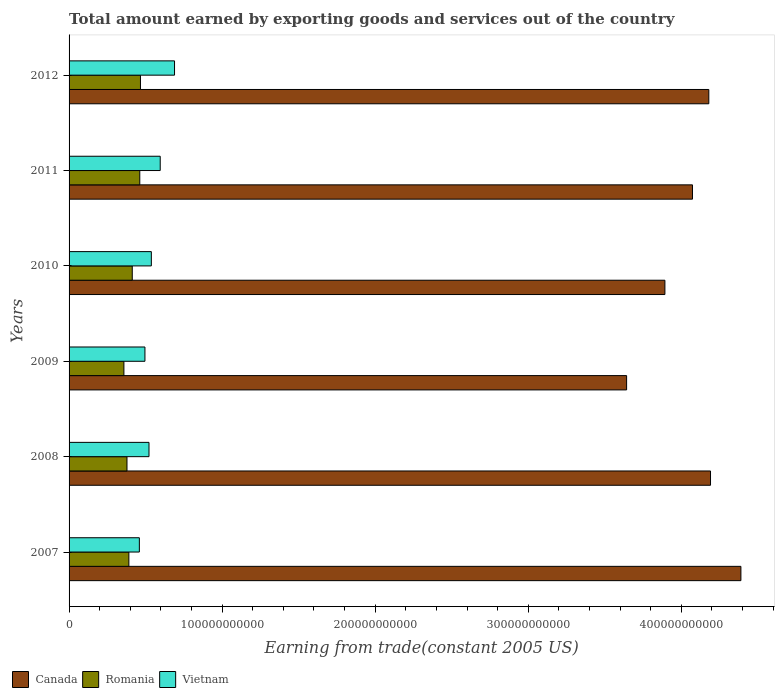How many different coloured bars are there?
Provide a succinct answer. 3. Are the number of bars per tick equal to the number of legend labels?
Give a very brief answer. Yes. How many bars are there on the 1st tick from the top?
Make the answer very short. 3. What is the label of the 1st group of bars from the top?
Keep it short and to the point. 2012. What is the total amount earned by exporting goods and services in Vietnam in 2011?
Give a very brief answer. 5.95e+1. Across all years, what is the maximum total amount earned by exporting goods and services in Vietnam?
Make the answer very short. 6.89e+1. Across all years, what is the minimum total amount earned by exporting goods and services in Canada?
Your answer should be very brief. 3.64e+11. In which year was the total amount earned by exporting goods and services in Canada maximum?
Make the answer very short. 2007. In which year was the total amount earned by exporting goods and services in Romania minimum?
Your answer should be compact. 2009. What is the total total amount earned by exporting goods and services in Canada in the graph?
Offer a very short reply. 2.44e+12. What is the difference between the total amount earned by exporting goods and services in Canada in 2007 and that in 2010?
Offer a terse response. 4.97e+1. What is the difference between the total amount earned by exporting goods and services in Vietnam in 2007 and the total amount earned by exporting goods and services in Canada in 2012?
Provide a succinct answer. -3.72e+11. What is the average total amount earned by exporting goods and services in Vietnam per year?
Give a very brief answer. 5.50e+1. In the year 2011, what is the difference between the total amount earned by exporting goods and services in Romania and total amount earned by exporting goods and services in Vietnam?
Provide a short and direct response. -1.34e+1. What is the ratio of the total amount earned by exporting goods and services in Canada in 2007 to that in 2009?
Provide a short and direct response. 1.2. What is the difference between the highest and the second highest total amount earned by exporting goods and services in Vietnam?
Your answer should be very brief. 9.35e+09. What is the difference between the highest and the lowest total amount earned by exporting goods and services in Romania?
Keep it short and to the point. 1.08e+1. Is the sum of the total amount earned by exporting goods and services in Canada in 2010 and 2011 greater than the maximum total amount earned by exporting goods and services in Vietnam across all years?
Make the answer very short. Yes. What does the 1st bar from the top in 2009 represents?
Provide a succinct answer. Vietnam. What does the 3rd bar from the bottom in 2012 represents?
Ensure brevity in your answer.  Vietnam. How many bars are there?
Your answer should be very brief. 18. Are all the bars in the graph horizontal?
Make the answer very short. Yes. How many years are there in the graph?
Give a very brief answer. 6. What is the difference between two consecutive major ticks on the X-axis?
Offer a terse response. 1.00e+11. Are the values on the major ticks of X-axis written in scientific E-notation?
Your answer should be compact. No. Does the graph contain any zero values?
Offer a terse response. No. How are the legend labels stacked?
Provide a succinct answer. Horizontal. What is the title of the graph?
Keep it short and to the point. Total amount earned by exporting goods and services out of the country. Does "Lithuania" appear as one of the legend labels in the graph?
Keep it short and to the point. No. What is the label or title of the X-axis?
Provide a succinct answer. Earning from trade(constant 2005 US). What is the label or title of the Y-axis?
Offer a terse response. Years. What is the Earning from trade(constant 2005 US) in Canada in 2007?
Keep it short and to the point. 4.39e+11. What is the Earning from trade(constant 2005 US) in Romania in 2007?
Your answer should be very brief. 3.91e+1. What is the Earning from trade(constant 2005 US) of Vietnam in 2007?
Make the answer very short. 4.59e+1. What is the Earning from trade(constant 2005 US) of Canada in 2008?
Ensure brevity in your answer.  4.19e+11. What is the Earning from trade(constant 2005 US) in Romania in 2008?
Your response must be concise. 3.78e+1. What is the Earning from trade(constant 2005 US) of Vietnam in 2008?
Your response must be concise. 5.22e+1. What is the Earning from trade(constant 2005 US) in Canada in 2009?
Offer a terse response. 3.64e+11. What is the Earning from trade(constant 2005 US) in Romania in 2009?
Provide a succinct answer. 3.58e+1. What is the Earning from trade(constant 2005 US) of Vietnam in 2009?
Your answer should be very brief. 4.96e+1. What is the Earning from trade(constant 2005 US) of Canada in 2010?
Your answer should be compact. 3.89e+11. What is the Earning from trade(constant 2005 US) of Romania in 2010?
Offer a very short reply. 4.13e+1. What is the Earning from trade(constant 2005 US) in Vietnam in 2010?
Offer a very short reply. 5.38e+1. What is the Earning from trade(constant 2005 US) in Canada in 2011?
Offer a very short reply. 4.07e+11. What is the Earning from trade(constant 2005 US) in Romania in 2011?
Offer a very short reply. 4.62e+1. What is the Earning from trade(constant 2005 US) in Vietnam in 2011?
Make the answer very short. 5.95e+1. What is the Earning from trade(constant 2005 US) of Canada in 2012?
Keep it short and to the point. 4.18e+11. What is the Earning from trade(constant 2005 US) in Romania in 2012?
Give a very brief answer. 4.67e+1. What is the Earning from trade(constant 2005 US) in Vietnam in 2012?
Provide a succinct answer. 6.89e+1. Across all years, what is the maximum Earning from trade(constant 2005 US) in Canada?
Give a very brief answer. 4.39e+11. Across all years, what is the maximum Earning from trade(constant 2005 US) of Romania?
Offer a terse response. 4.67e+1. Across all years, what is the maximum Earning from trade(constant 2005 US) of Vietnam?
Keep it short and to the point. 6.89e+1. Across all years, what is the minimum Earning from trade(constant 2005 US) of Canada?
Provide a short and direct response. 3.64e+11. Across all years, what is the minimum Earning from trade(constant 2005 US) of Romania?
Your answer should be compact. 3.58e+1. Across all years, what is the minimum Earning from trade(constant 2005 US) of Vietnam?
Your answer should be very brief. 4.59e+1. What is the total Earning from trade(constant 2005 US) in Canada in the graph?
Provide a short and direct response. 2.44e+12. What is the total Earning from trade(constant 2005 US) in Romania in the graph?
Your response must be concise. 2.47e+11. What is the total Earning from trade(constant 2005 US) in Vietnam in the graph?
Your answer should be compact. 3.30e+11. What is the difference between the Earning from trade(constant 2005 US) of Canada in 2007 and that in 2008?
Your response must be concise. 1.99e+1. What is the difference between the Earning from trade(constant 2005 US) of Romania in 2007 and that in 2008?
Provide a succinct answer. 1.23e+09. What is the difference between the Earning from trade(constant 2005 US) of Vietnam in 2007 and that in 2008?
Your answer should be very brief. -6.29e+09. What is the difference between the Earning from trade(constant 2005 US) in Canada in 2007 and that in 2009?
Keep it short and to the point. 7.47e+1. What is the difference between the Earning from trade(constant 2005 US) in Romania in 2007 and that in 2009?
Your answer should be compact. 3.25e+09. What is the difference between the Earning from trade(constant 2005 US) in Vietnam in 2007 and that in 2009?
Offer a terse response. -3.64e+09. What is the difference between the Earning from trade(constant 2005 US) in Canada in 2007 and that in 2010?
Give a very brief answer. 4.97e+1. What is the difference between the Earning from trade(constant 2005 US) of Romania in 2007 and that in 2010?
Make the answer very short. -2.21e+09. What is the difference between the Earning from trade(constant 2005 US) of Vietnam in 2007 and that in 2010?
Provide a succinct answer. -7.82e+09. What is the difference between the Earning from trade(constant 2005 US) in Canada in 2007 and that in 2011?
Provide a short and direct response. 3.16e+1. What is the difference between the Earning from trade(constant 2005 US) of Romania in 2007 and that in 2011?
Give a very brief answer. -7.12e+09. What is the difference between the Earning from trade(constant 2005 US) in Vietnam in 2007 and that in 2011?
Offer a very short reply. -1.36e+1. What is the difference between the Earning from trade(constant 2005 US) of Canada in 2007 and that in 2012?
Your answer should be compact. 2.10e+1. What is the difference between the Earning from trade(constant 2005 US) of Romania in 2007 and that in 2012?
Give a very brief answer. -7.58e+09. What is the difference between the Earning from trade(constant 2005 US) in Vietnam in 2007 and that in 2012?
Offer a terse response. -2.30e+1. What is the difference between the Earning from trade(constant 2005 US) of Canada in 2008 and that in 2009?
Provide a succinct answer. 5.48e+1. What is the difference between the Earning from trade(constant 2005 US) of Romania in 2008 and that in 2009?
Offer a terse response. 2.01e+09. What is the difference between the Earning from trade(constant 2005 US) in Vietnam in 2008 and that in 2009?
Your answer should be compact. 2.66e+09. What is the difference between the Earning from trade(constant 2005 US) of Canada in 2008 and that in 2010?
Offer a very short reply. 2.98e+1. What is the difference between the Earning from trade(constant 2005 US) of Romania in 2008 and that in 2010?
Ensure brevity in your answer.  -3.44e+09. What is the difference between the Earning from trade(constant 2005 US) of Vietnam in 2008 and that in 2010?
Your answer should be compact. -1.53e+09. What is the difference between the Earning from trade(constant 2005 US) of Canada in 2008 and that in 2011?
Provide a succinct answer. 1.18e+1. What is the difference between the Earning from trade(constant 2005 US) in Romania in 2008 and that in 2011?
Your answer should be compact. -8.35e+09. What is the difference between the Earning from trade(constant 2005 US) of Vietnam in 2008 and that in 2011?
Your response must be concise. -7.33e+09. What is the difference between the Earning from trade(constant 2005 US) in Canada in 2008 and that in 2012?
Make the answer very short. 1.12e+09. What is the difference between the Earning from trade(constant 2005 US) in Romania in 2008 and that in 2012?
Provide a succinct answer. -8.81e+09. What is the difference between the Earning from trade(constant 2005 US) in Vietnam in 2008 and that in 2012?
Your answer should be compact. -1.67e+1. What is the difference between the Earning from trade(constant 2005 US) in Canada in 2009 and that in 2010?
Provide a short and direct response. -2.50e+1. What is the difference between the Earning from trade(constant 2005 US) in Romania in 2009 and that in 2010?
Your response must be concise. -5.46e+09. What is the difference between the Earning from trade(constant 2005 US) in Vietnam in 2009 and that in 2010?
Give a very brief answer. -4.19e+09. What is the difference between the Earning from trade(constant 2005 US) of Canada in 2009 and that in 2011?
Ensure brevity in your answer.  -4.30e+1. What is the difference between the Earning from trade(constant 2005 US) in Romania in 2009 and that in 2011?
Your response must be concise. -1.04e+1. What is the difference between the Earning from trade(constant 2005 US) of Vietnam in 2009 and that in 2011?
Make the answer very short. -9.98e+09. What is the difference between the Earning from trade(constant 2005 US) of Canada in 2009 and that in 2012?
Ensure brevity in your answer.  -5.37e+1. What is the difference between the Earning from trade(constant 2005 US) in Romania in 2009 and that in 2012?
Make the answer very short. -1.08e+1. What is the difference between the Earning from trade(constant 2005 US) in Vietnam in 2009 and that in 2012?
Provide a short and direct response. -1.93e+1. What is the difference between the Earning from trade(constant 2005 US) in Canada in 2010 and that in 2011?
Provide a succinct answer. -1.80e+1. What is the difference between the Earning from trade(constant 2005 US) of Romania in 2010 and that in 2011?
Provide a succinct answer. -4.91e+09. What is the difference between the Earning from trade(constant 2005 US) in Vietnam in 2010 and that in 2011?
Your answer should be compact. -5.80e+09. What is the difference between the Earning from trade(constant 2005 US) in Canada in 2010 and that in 2012?
Provide a short and direct response. -2.87e+1. What is the difference between the Earning from trade(constant 2005 US) in Romania in 2010 and that in 2012?
Offer a terse response. -5.37e+09. What is the difference between the Earning from trade(constant 2005 US) of Vietnam in 2010 and that in 2012?
Ensure brevity in your answer.  -1.52e+1. What is the difference between the Earning from trade(constant 2005 US) in Canada in 2011 and that in 2012?
Your answer should be compact. -1.07e+1. What is the difference between the Earning from trade(constant 2005 US) in Romania in 2011 and that in 2012?
Ensure brevity in your answer.  -4.58e+08. What is the difference between the Earning from trade(constant 2005 US) of Vietnam in 2011 and that in 2012?
Give a very brief answer. -9.35e+09. What is the difference between the Earning from trade(constant 2005 US) in Canada in 2007 and the Earning from trade(constant 2005 US) in Romania in 2008?
Give a very brief answer. 4.01e+11. What is the difference between the Earning from trade(constant 2005 US) of Canada in 2007 and the Earning from trade(constant 2005 US) of Vietnam in 2008?
Offer a very short reply. 3.87e+11. What is the difference between the Earning from trade(constant 2005 US) of Romania in 2007 and the Earning from trade(constant 2005 US) of Vietnam in 2008?
Give a very brief answer. -1.31e+1. What is the difference between the Earning from trade(constant 2005 US) in Canada in 2007 and the Earning from trade(constant 2005 US) in Romania in 2009?
Provide a succinct answer. 4.03e+11. What is the difference between the Earning from trade(constant 2005 US) in Canada in 2007 and the Earning from trade(constant 2005 US) in Vietnam in 2009?
Your response must be concise. 3.89e+11. What is the difference between the Earning from trade(constant 2005 US) of Romania in 2007 and the Earning from trade(constant 2005 US) of Vietnam in 2009?
Your response must be concise. -1.05e+1. What is the difference between the Earning from trade(constant 2005 US) in Canada in 2007 and the Earning from trade(constant 2005 US) in Romania in 2010?
Offer a terse response. 3.98e+11. What is the difference between the Earning from trade(constant 2005 US) of Canada in 2007 and the Earning from trade(constant 2005 US) of Vietnam in 2010?
Your answer should be compact. 3.85e+11. What is the difference between the Earning from trade(constant 2005 US) in Romania in 2007 and the Earning from trade(constant 2005 US) in Vietnam in 2010?
Keep it short and to the point. -1.47e+1. What is the difference between the Earning from trade(constant 2005 US) of Canada in 2007 and the Earning from trade(constant 2005 US) of Romania in 2011?
Make the answer very short. 3.93e+11. What is the difference between the Earning from trade(constant 2005 US) of Canada in 2007 and the Earning from trade(constant 2005 US) of Vietnam in 2011?
Your response must be concise. 3.79e+11. What is the difference between the Earning from trade(constant 2005 US) of Romania in 2007 and the Earning from trade(constant 2005 US) of Vietnam in 2011?
Keep it short and to the point. -2.05e+1. What is the difference between the Earning from trade(constant 2005 US) of Canada in 2007 and the Earning from trade(constant 2005 US) of Romania in 2012?
Ensure brevity in your answer.  3.92e+11. What is the difference between the Earning from trade(constant 2005 US) of Canada in 2007 and the Earning from trade(constant 2005 US) of Vietnam in 2012?
Keep it short and to the point. 3.70e+11. What is the difference between the Earning from trade(constant 2005 US) of Romania in 2007 and the Earning from trade(constant 2005 US) of Vietnam in 2012?
Keep it short and to the point. -2.98e+1. What is the difference between the Earning from trade(constant 2005 US) in Canada in 2008 and the Earning from trade(constant 2005 US) in Romania in 2009?
Provide a short and direct response. 3.83e+11. What is the difference between the Earning from trade(constant 2005 US) of Canada in 2008 and the Earning from trade(constant 2005 US) of Vietnam in 2009?
Give a very brief answer. 3.70e+11. What is the difference between the Earning from trade(constant 2005 US) of Romania in 2008 and the Earning from trade(constant 2005 US) of Vietnam in 2009?
Give a very brief answer. -1.17e+1. What is the difference between the Earning from trade(constant 2005 US) of Canada in 2008 and the Earning from trade(constant 2005 US) of Romania in 2010?
Your answer should be compact. 3.78e+11. What is the difference between the Earning from trade(constant 2005 US) in Canada in 2008 and the Earning from trade(constant 2005 US) in Vietnam in 2010?
Make the answer very short. 3.65e+11. What is the difference between the Earning from trade(constant 2005 US) in Romania in 2008 and the Earning from trade(constant 2005 US) in Vietnam in 2010?
Ensure brevity in your answer.  -1.59e+1. What is the difference between the Earning from trade(constant 2005 US) of Canada in 2008 and the Earning from trade(constant 2005 US) of Romania in 2011?
Your answer should be compact. 3.73e+11. What is the difference between the Earning from trade(constant 2005 US) in Canada in 2008 and the Earning from trade(constant 2005 US) in Vietnam in 2011?
Your answer should be compact. 3.60e+11. What is the difference between the Earning from trade(constant 2005 US) in Romania in 2008 and the Earning from trade(constant 2005 US) in Vietnam in 2011?
Offer a very short reply. -2.17e+1. What is the difference between the Earning from trade(constant 2005 US) of Canada in 2008 and the Earning from trade(constant 2005 US) of Romania in 2012?
Provide a succinct answer. 3.72e+11. What is the difference between the Earning from trade(constant 2005 US) in Canada in 2008 and the Earning from trade(constant 2005 US) in Vietnam in 2012?
Offer a very short reply. 3.50e+11. What is the difference between the Earning from trade(constant 2005 US) in Romania in 2008 and the Earning from trade(constant 2005 US) in Vietnam in 2012?
Offer a terse response. -3.11e+1. What is the difference between the Earning from trade(constant 2005 US) of Canada in 2009 and the Earning from trade(constant 2005 US) of Romania in 2010?
Your answer should be compact. 3.23e+11. What is the difference between the Earning from trade(constant 2005 US) of Canada in 2009 and the Earning from trade(constant 2005 US) of Vietnam in 2010?
Provide a succinct answer. 3.11e+11. What is the difference between the Earning from trade(constant 2005 US) of Romania in 2009 and the Earning from trade(constant 2005 US) of Vietnam in 2010?
Provide a short and direct response. -1.79e+1. What is the difference between the Earning from trade(constant 2005 US) in Canada in 2009 and the Earning from trade(constant 2005 US) in Romania in 2011?
Make the answer very short. 3.18e+11. What is the difference between the Earning from trade(constant 2005 US) in Canada in 2009 and the Earning from trade(constant 2005 US) in Vietnam in 2011?
Offer a terse response. 3.05e+11. What is the difference between the Earning from trade(constant 2005 US) of Romania in 2009 and the Earning from trade(constant 2005 US) of Vietnam in 2011?
Make the answer very short. -2.37e+1. What is the difference between the Earning from trade(constant 2005 US) in Canada in 2009 and the Earning from trade(constant 2005 US) in Romania in 2012?
Keep it short and to the point. 3.18e+11. What is the difference between the Earning from trade(constant 2005 US) of Canada in 2009 and the Earning from trade(constant 2005 US) of Vietnam in 2012?
Provide a short and direct response. 2.95e+11. What is the difference between the Earning from trade(constant 2005 US) in Romania in 2009 and the Earning from trade(constant 2005 US) in Vietnam in 2012?
Offer a terse response. -3.31e+1. What is the difference between the Earning from trade(constant 2005 US) of Canada in 2010 and the Earning from trade(constant 2005 US) of Romania in 2011?
Keep it short and to the point. 3.43e+11. What is the difference between the Earning from trade(constant 2005 US) of Canada in 2010 and the Earning from trade(constant 2005 US) of Vietnam in 2011?
Provide a succinct answer. 3.30e+11. What is the difference between the Earning from trade(constant 2005 US) of Romania in 2010 and the Earning from trade(constant 2005 US) of Vietnam in 2011?
Your response must be concise. -1.83e+1. What is the difference between the Earning from trade(constant 2005 US) of Canada in 2010 and the Earning from trade(constant 2005 US) of Romania in 2012?
Ensure brevity in your answer.  3.43e+11. What is the difference between the Earning from trade(constant 2005 US) in Canada in 2010 and the Earning from trade(constant 2005 US) in Vietnam in 2012?
Offer a very short reply. 3.20e+11. What is the difference between the Earning from trade(constant 2005 US) in Romania in 2010 and the Earning from trade(constant 2005 US) in Vietnam in 2012?
Offer a very short reply. -2.76e+1. What is the difference between the Earning from trade(constant 2005 US) of Canada in 2011 and the Earning from trade(constant 2005 US) of Romania in 2012?
Make the answer very short. 3.61e+11. What is the difference between the Earning from trade(constant 2005 US) of Canada in 2011 and the Earning from trade(constant 2005 US) of Vietnam in 2012?
Your answer should be very brief. 3.38e+11. What is the difference between the Earning from trade(constant 2005 US) in Romania in 2011 and the Earning from trade(constant 2005 US) in Vietnam in 2012?
Give a very brief answer. -2.27e+1. What is the average Earning from trade(constant 2005 US) in Canada per year?
Your answer should be compact. 4.06e+11. What is the average Earning from trade(constant 2005 US) of Romania per year?
Provide a succinct answer. 4.11e+1. What is the average Earning from trade(constant 2005 US) in Vietnam per year?
Your answer should be very brief. 5.50e+1. In the year 2007, what is the difference between the Earning from trade(constant 2005 US) of Canada and Earning from trade(constant 2005 US) of Romania?
Your response must be concise. 4.00e+11. In the year 2007, what is the difference between the Earning from trade(constant 2005 US) of Canada and Earning from trade(constant 2005 US) of Vietnam?
Offer a terse response. 3.93e+11. In the year 2007, what is the difference between the Earning from trade(constant 2005 US) of Romania and Earning from trade(constant 2005 US) of Vietnam?
Make the answer very short. -6.85e+09. In the year 2008, what is the difference between the Earning from trade(constant 2005 US) of Canada and Earning from trade(constant 2005 US) of Romania?
Ensure brevity in your answer.  3.81e+11. In the year 2008, what is the difference between the Earning from trade(constant 2005 US) of Canada and Earning from trade(constant 2005 US) of Vietnam?
Provide a succinct answer. 3.67e+11. In the year 2008, what is the difference between the Earning from trade(constant 2005 US) in Romania and Earning from trade(constant 2005 US) in Vietnam?
Your answer should be compact. -1.44e+1. In the year 2009, what is the difference between the Earning from trade(constant 2005 US) in Canada and Earning from trade(constant 2005 US) in Romania?
Your response must be concise. 3.28e+11. In the year 2009, what is the difference between the Earning from trade(constant 2005 US) of Canada and Earning from trade(constant 2005 US) of Vietnam?
Provide a succinct answer. 3.15e+11. In the year 2009, what is the difference between the Earning from trade(constant 2005 US) of Romania and Earning from trade(constant 2005 US) of Vietnam?
Your response must be concise. -1.37e+1. In the year 2010, what is the difference between the Earning from trade(constant 2005 US) of Canada and Earning from trade(constant 2005 US) of Romania?
Offer a very short reply. 3.48e+11. In the year 2010, what is the difference between the Earning from trade(constant 2005 US) of Canada and Earning from trade(constant 2005 US) of Vietnam?
Your response must be concise. 3.36e+11. In the year 2010, what is the difference between the Earning from trade(constant 2005 US) of Romania and Earning from trade(constant 2005 US) of Vietnam?
Give a very brief answer. -1.25e+1. In the year 2011, what is the difference between the Earning from trade(constant 2005 US) of Canada and Earning from trade(constant 2005 US) of Romania?
Offer a very short reply. 3.61e+11. In the year 2011, what is the difference between the Earning from trade(constant 2005 US) in Canada and Earning from trade(constant 2005 US) in Vietnam?
Provide a short and direct response. 3.48e+11. In the year 2011, what is the difference between the Earning from trade(constant 2005 US) in Romania and Earning from trade(constant 2005 US) in Vietnam?
Keep it short and to the point. -1.34e+1. In the year 2012, what is the difference between the Earning from trade(constant 2005 US) of Canada and Earning from trade(constant 2005 US) of Romania?
Provide a short and direct response. 3.71e+11. In the year 2012, what is the difference between the Earning from trade(constant 2005 US) of Canada and Earning from trade(constant 2005 US) of Vietnam?
Make the answer very short. 3.49e+11. In the year 2012, what is the difference between the Earning from trade(constant 2005 US) of Romania and Earning from trade(constant 2005 US) of Vietnam?
Provide a succinct answer. -2.23e+1. What is the ratio of the Earning from trade(constant 2005 US) in Canada in 2007 to that in 2008?
Keep it short and to the point. 1.05. What is the ratio of the Earning from trade(constant 2005 US) in Romania in 2007 to that in 2008?
Your response must be concise. 1.03. What is the ratio of the Earning from trade(constant 2005 US) in Vietnam in 2007 to that in 2008?
Keep it short and to the point. 0.88. What is the ratio of the Earning from trade(constant 2005 US) of Canada in 2007 to that in 2009?
Provide a succinct answer. 1.21. What is the ratio of the Earning from trade(constant 2005 US) of Romania in 2007 to that in 2009?
Keep it short and to the point. 1.09. What is the ratio of the Earning from trade(constant 2005 US) in Vietnam in 2007 to that in 2009?
Make the answer very short. 0.93. What is the ratio of the Earning from trade(constant 2005 US) in Canada in 2007 to that in 2010?
Give a very brief answer. 1.13. What is the ratio of the Earning from trade(constant 2005 US) in Romania in 2007 to that in 2010?
Ensure brevity in your answer.  0.95. What is the ratio of the Earning from trade(constant 2005 US) in Vietnam in 2007 to that in 2010?
Provide a short and direct response. 0.85. What is the ratio of the Earning from trade(constant 2005 US) in Canada in 2007 to that in 2011?
Provide a succinct answer. 1.08. What is the ratio of the Earning from trade(constant 2005 US) of Romania in 2007 to that in 2011?
Offer a very short reply. 0.85. What is the ratio of the Earning from trade(constant 2005 US) in Vietnam in 2007 to that in 2011?
Ensure brevity in your answer.  0.77. What is the ratio of the Earning from trade(constant 2005 US) in Canada in 2007 to that in 2012?
Ensure brevity in your answer.  1.05. What is the ratio of the Earning from trade(constant 2005 US) of Romania in 2007 to that in 2012?
Offer a very short reply. 0.84. What is the ratio of the Earning from trade(constant 2005 US) of Vietnam in 2007 to that in 2012?
Your response must be concise. 0.67. What is the ratio of the Earning from trade(constant 2005 US) in Canada in 2008 to that in 2009?
Your answer should be compact. 1.15. What is the ratio of the Earning from trade(constant 2005 US) in Romania in 2008 to that in 2009?
Provide a succinct answer. 1.06. What is the ratio of the Earning from trade(constant 2005 US) in Vietnam in 2008 to that in 2009?
Offer a very short reply. 1.05. What is the ratio of the Earning from trade(constant 2005 US) in Canada in 2008 to that in 2010?
Ensure brevity in your answer.  1.08. What is the ratio of the Earning from trade(constant 2005 US) of Romania in 2008 to that in 2010?
Your response must be concise. 0.92. What is the ratio of the Earning from trade(constant 2005 US) in Vietnam in 2008 to that in 2010?
Ensure brevity in your answer.  0.97. What is the ratio of the Earning from trade(constant 2005 US) in Canada in 2008 to that in 2011?
Offer a very short reply. 1.03. What is the ratio of the Earning from trade(constant 2005 US) in Romania in 2008 to that in 2011?
Your response must be concise. 0.82. What is the ratio of the Earning from trade(constant 2005 US) in Vietnam in 2008 to that in 2011?
Your answer should be very brief. 0.88. What is the ratio of the Earning from trade(constant 2005 US) of Canada in 2008 to that in 2012?
Your response must be concise. 1. What is the ratio of the Earning from trade(constant 2005 US) in Romania in 2008 to that in 2012?
Provide a succinct answer. 0.81. What is the ratio of the Earning from trade(constant 2005 US) of Vietnam in 2008 to that in 2012?
Keep it short and to the point. 0.76. What is the ratio of the Earning from trade(constant 2005 US) of Canada in 2009 to that in 2010?
Ensure brevity in your answer.  0.94. What is the ratio of the Earning from trade(constant 2005 US) in Romania in 2009 to that in 2010?
Make the answer very short. 0.87. What is the ratio of the Earning from trade(constant 2005 US) of Vietnam in 2009 to that in 2010?
Provide a succinct answer. 0.92. What is the ratio of the Earning from trade(constant 2005 US) in Canada in 2009 to that in 2011?
Your response must be concise. 0.89. What is the ratio of the Earning from trade(constant 2005 US) in Romania in 2009 to that in 2011?
Make the answer very short. 0.78. What is the ratio of the Earning from trade(constant 2005 US) in Vietnam in 2009 to that in 2011?
Offer a very short reply. 0.83. What is the ratio of the Earning from trade(constant 2005 US) of Canada in 2009 to that in 2012?
Offer a terse response. 0.87. What is the ratio of the Earning from trade(constant 2005 US) in Romania in 2009 to that in 2012?
Ensure brevity in your answer.  0.77. What is the ratio of the Earning from trade(constant 2005 US) in Vietnam in 2009 to that in 2012?
Your response must be concise. 0.72. What is the ratio of the Earning from trade(constant 2005 US) of Canada in 2010 to that in 2011?
Offer a terse response. 0.96. What is the ratio of the Earning from trade(constant 2005 US) in Romania in 2010 to that in 2011?
Make the answer very short. 0.89. What is the ratio of the Earning from trade(constant 2005 US) in Vietnam in 2010 to that in 2011?
Your answer should be very brief. 0.9. What is the ratio of the Earning from trade(constant 2005 US) of Canada in 2010 to that in 2012?
Your response must be concise. 0.93. What is the ratio of the Earning from trade(constant 2005 US) in Romania in 2010 to that in 2012?
Keep it short and to the point. 0.89. What is the ratio of the Earning from trade(constant 2005 US) in Vietnam in 2010 to that in 2012?
Offer a terse response. 0.78. What is the ratio of the Earning from trade(constant 2005 US) in Canada in 2011 to that in 2012?
Offer a very short reply. 0.97. What is the ratio of the Earning from trade(constant 2005 US) of Romania in 2011 to that in 2012?
Provide a short and direct response. 0.99. What is the ratio of the Earning from trade(constant 2005 US) in Vietnam in 2011 to that in 2012?
Your answer should be compact. 0.86. What is the difference between the highest and the second highest Earning from trade(constant 2005 US) of Canada?
Provide a succinct answer. 1.99e+1. What is the difference between the highest and the second highest Earning from trade(constant 2005 US) of Romania?
Your answer should be very brief. 4.58e+08. What is the difference between the highest and the second highest Earning from trade(constant 2005 US) in Vietnam?
Your response must be concise. 9.35e+09. What is the difference between the highest and the lowest Earning from trade(constant 2005 US) in Canada?
Your answer should be very brief. 7.47e+1. What is the difference between the highest and the lowest Earning from trade(constant 2005 US) of Romania?
Provide a succinct answer. 1.08e+1. What is the difference between the highest and the lowest Earning from trade(constant 2005 US) in Vietnam?
Keep it short and to the point. 2.30e+1. 